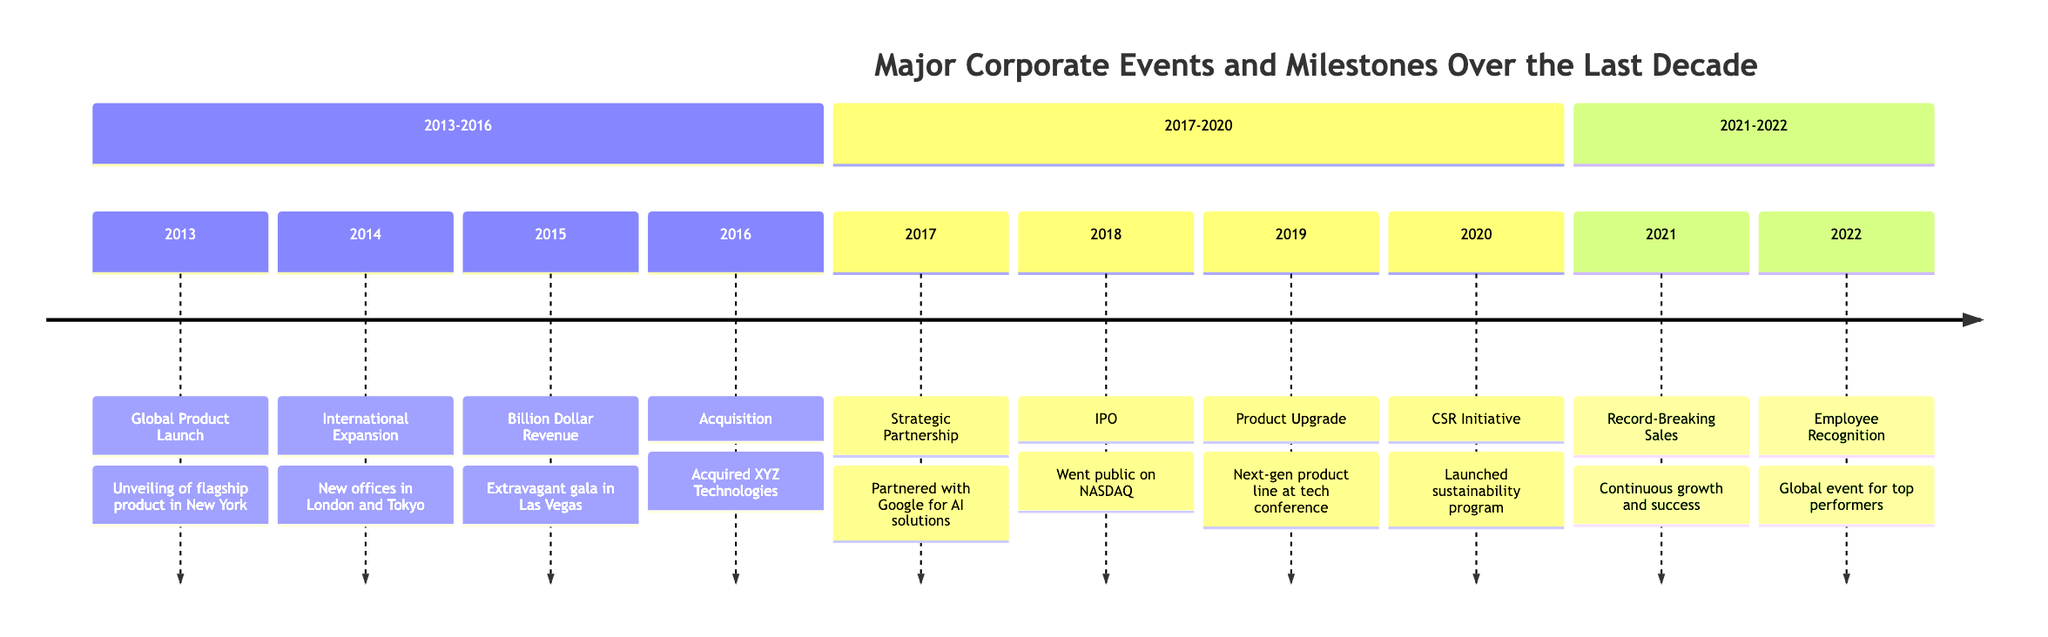What year did the Global Product Launch occur? The Global Product Launch is labeled with the year 2013 in the timeline. Thus, by identifying the event and checking its year, we find that it occurred in 2013.
Answer: 2013 How many major corporate events occurred in 2018? In the timeline, there is only one event listed for the year 2018, which is the IPO. Therefore, the total count of major corporate events for that year is one.
Answer: 1 What significant milestone was celebrated in 2015? The timeline states that in 2015, the event labeled is 'Billion Dollar Revenue Milestone'. Therefore, this is the significant milestone celebrated in that year.
Answer: Billion Dollar Revenue Milestone Which company did we partner with in 2017? The timeline indicates a strategic partnership with Google in 2017. By looking up the event within that year, we can ascertain the partner company mentioned.
Answer: Google What event precedes the IPO in 2018 on the timeline? The IPO in 2018 is preceded by the event 'Partnership with Global Brand' that occurred in 2017. Therefore, the event that comes before the IPO is the partnership event.
Answer: Partnership with Global Brand What does the CSR initiative focus on, and in what year was it launched? The CSR initiative was launched in 2020 according to the timeline, and it focuses on sustainability and community development, as described in the event details.
Answer: Sustainability and community development, 2020 How many total years are represented in this timeline? The timeline spans from 2013 to 2022, which means it encompasses a range of 10 years total, as you can count from the start year to the end year.
Answer: 10 Which event in the timeline signifies our record-breaking sales year? According to the timeline, the event labeled 'Record-Breaking Sales Year' took place in 2021, marking the specific year of this significant company achievement.
Answer: Record-Breaking Sales Year 